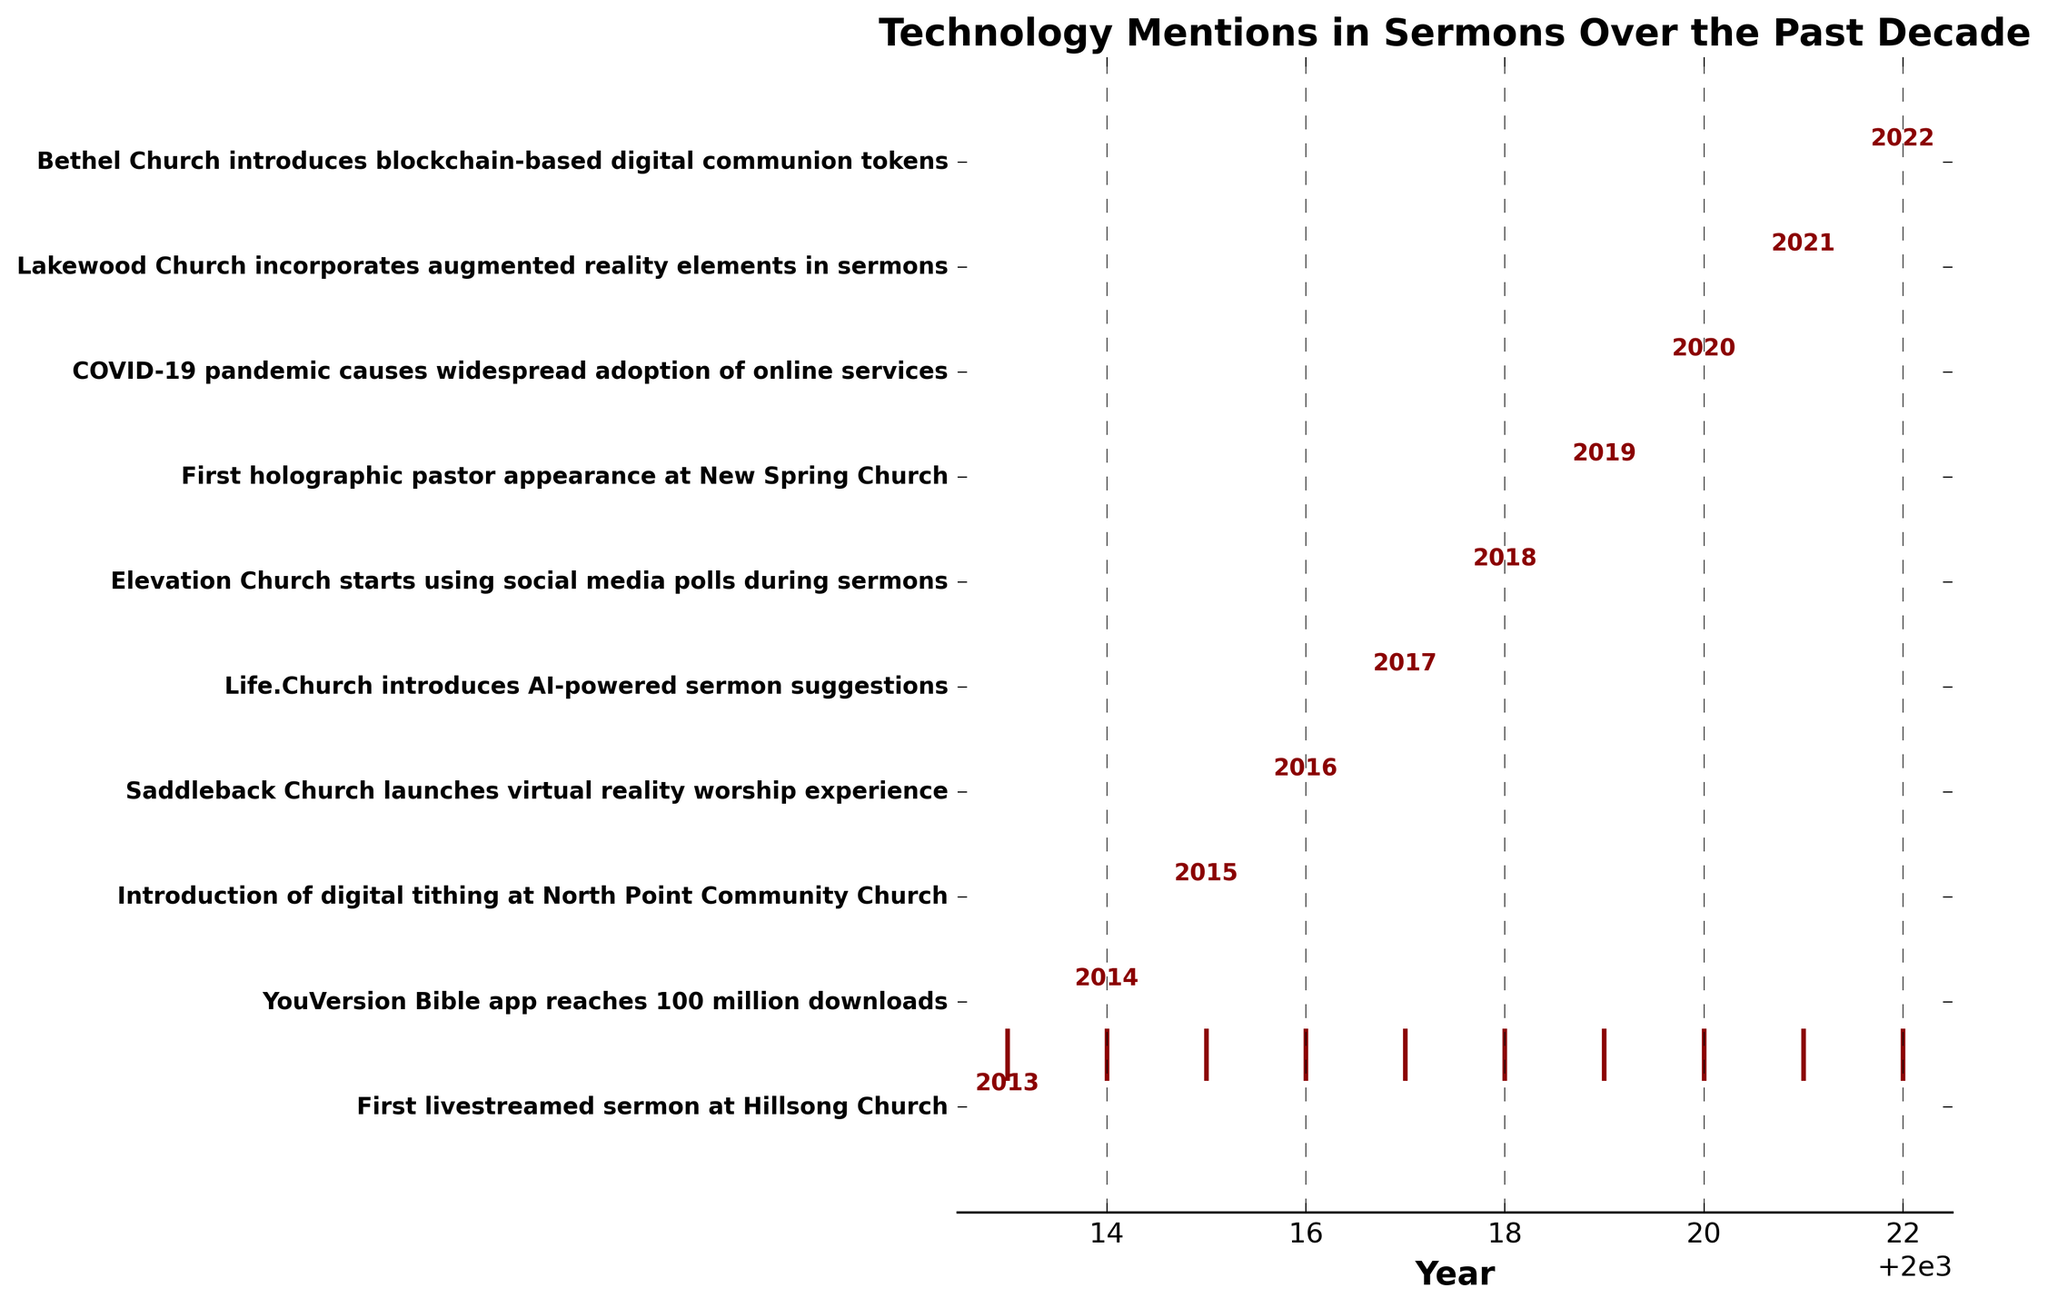What is the title of the figure? The title of the figure is displayed prominently at the top of the plot. It reads "Technology Mentions in Sermons Over the Past Decade".
Answer: Technology Mentions in Sermons Over the Past Decade How many events related to technology mentions are plotted in the figure? The figure lists several events vertically along the y-axis, each corresponding to a specific year. By counting the events, we find that there are 10 events listed.
Answer: 10 Which year shows the first event related to technology mentions in sermons? To find the first event, we look for the earliest year listed on the x-axis. The first event is "First livestreamed sermon at Hillsong Church," which occurred in 2013.
Answer: 2013 Does the majority of technology mentions in sermons occur before or after 2018? To determine this, we need to count the number of events before and after 2018. There are 5 events before 2018 and 5 events from 2018 onward.
Answer: Equal Comparing the years 2016 and 2018, in which year did the church introduce a more interactive form of worship? For 2016, the event is "Saddleback Church launches virtual reality worship experience." For 2018, the event is "Elevation Church starts using social media polls during sermons." The 2018 event is more interactive as it involves direct interaction with the audience.
Answer: 2018 What year is annotated on the event labeled "COVID-19 pandemic causes widespread adoption of online services"? We look for the event labeled "COVID-19 pandemic causes widespread adoption of online services" and find its annotation at the year 2020.
Answer: 2020 Which church introduced augmented reality elements in sermons, and in which year did this occur? The event of introducing augmented reality elements in sermons is listed as occurring at Lakewood Church in the year 2021.
Answer: Lakewood Church, 2021 How many years separate the introduction of digital tithing from the first holographic pastor appearance? Digital tithing was introduced in 2015 and the first holographic pastor appearance occurred in 2019. The difference between these years is 4 years (2019 - 2015).
Answer: 4 years Which church introduced blockchain-based digital communion tokens, and in which year did this happen? The event regarding blockchain-based digital communion tokens is labeled under Bethel Church and happened in the year 2022.
Answer: Bethel Church, 2022 